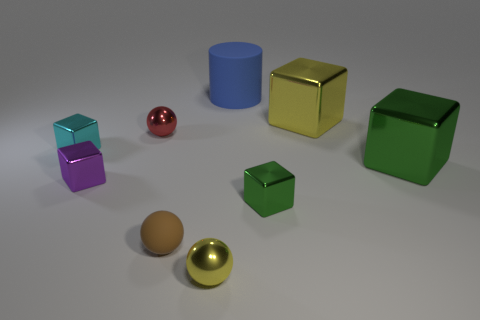Are there an equal number of small balls right of the large blue cylinder and metallic cubes that are right of the tiny yellow shiny thing?
Offer a terse response. No. The other large metal thing that is the same shape as the big yellow shiny object is what color?
Provide a short and direct response. Green. Is there any other thing that is the same color as the large cylinder?
Your answer should be very brief. No. What number of matte things are either cyan blocks or tiny things?
Provide a short and direct response. 1. Is the color of the small matte sphere the same as the big cylinder?
Your answer should be compact. No. Are there more red objects that are behind the large blue matte cylinder than small metal things?
Your answer should be compact. No. What number of other objects are the same material as the blue cylinder?
Your response must be concise. 1. How many big objects are either yellow shiny balls or blue matte things?
Give a very brief answer. 1. Is the yellow cube made of the same material as the small red thing?
Offer a terse response. Yes. There is a yellow metal thing behind the cyan thing; how many green metal cubes are on the left side of it?
Provide a succinct answer. 1. 